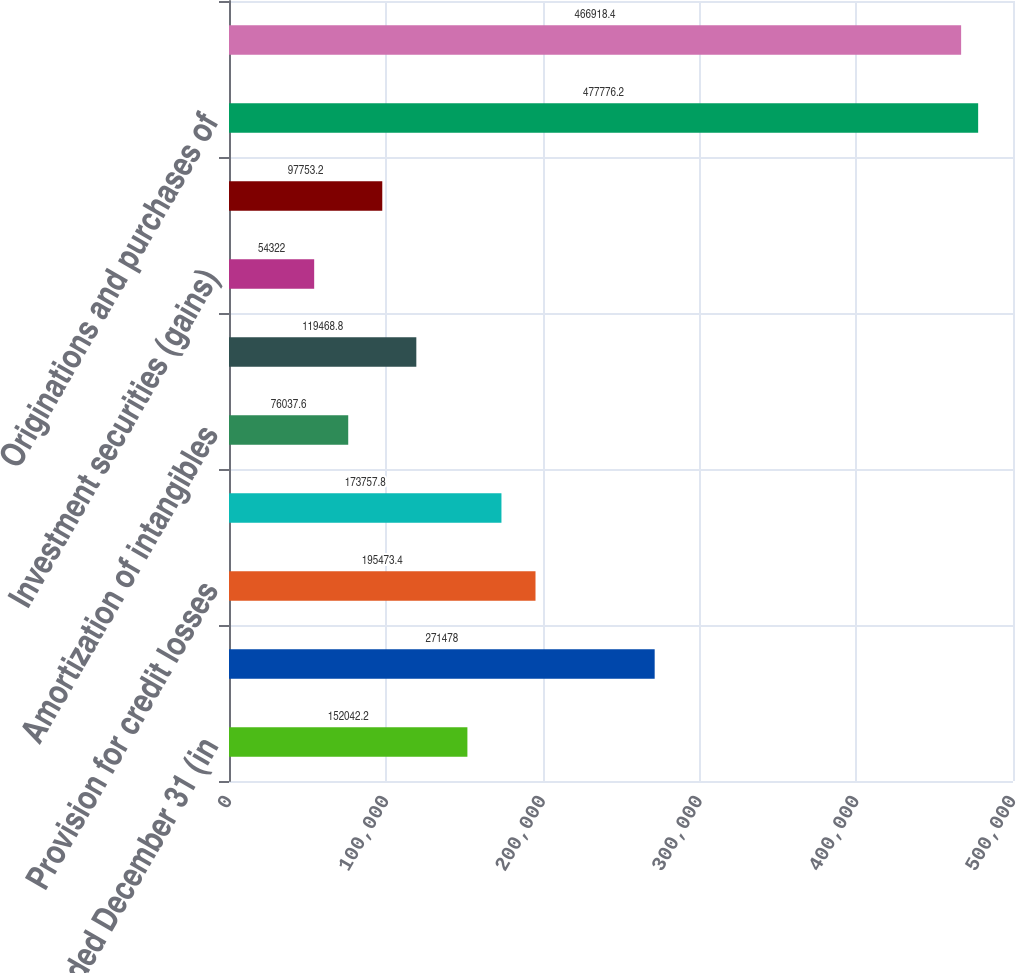Convert chart to OTSL. <chart><loc_0><loc_0><loc_500><loc_500><bar_chart><fcel>Year ended December 31 (in<fcel>Net income<fcel>Provision for credit losses<fcel>Depreciation and amortization<fcel>Amortization of intangibles<fcel>Deferred tax expense (benefit)<fcel>Investment securities (gains)<fcel>Stock-based compensation<fcel>Originations and purchases of<fcel>Proceeds from sales and<nl><fcel>152042<fcel>271478<fcel>195473<fcel>173758<fcel>76037.6<fcel>119469<fcel>54322<fcel>97753.2<fcel>477776<fcel>466918<nl></chart> 